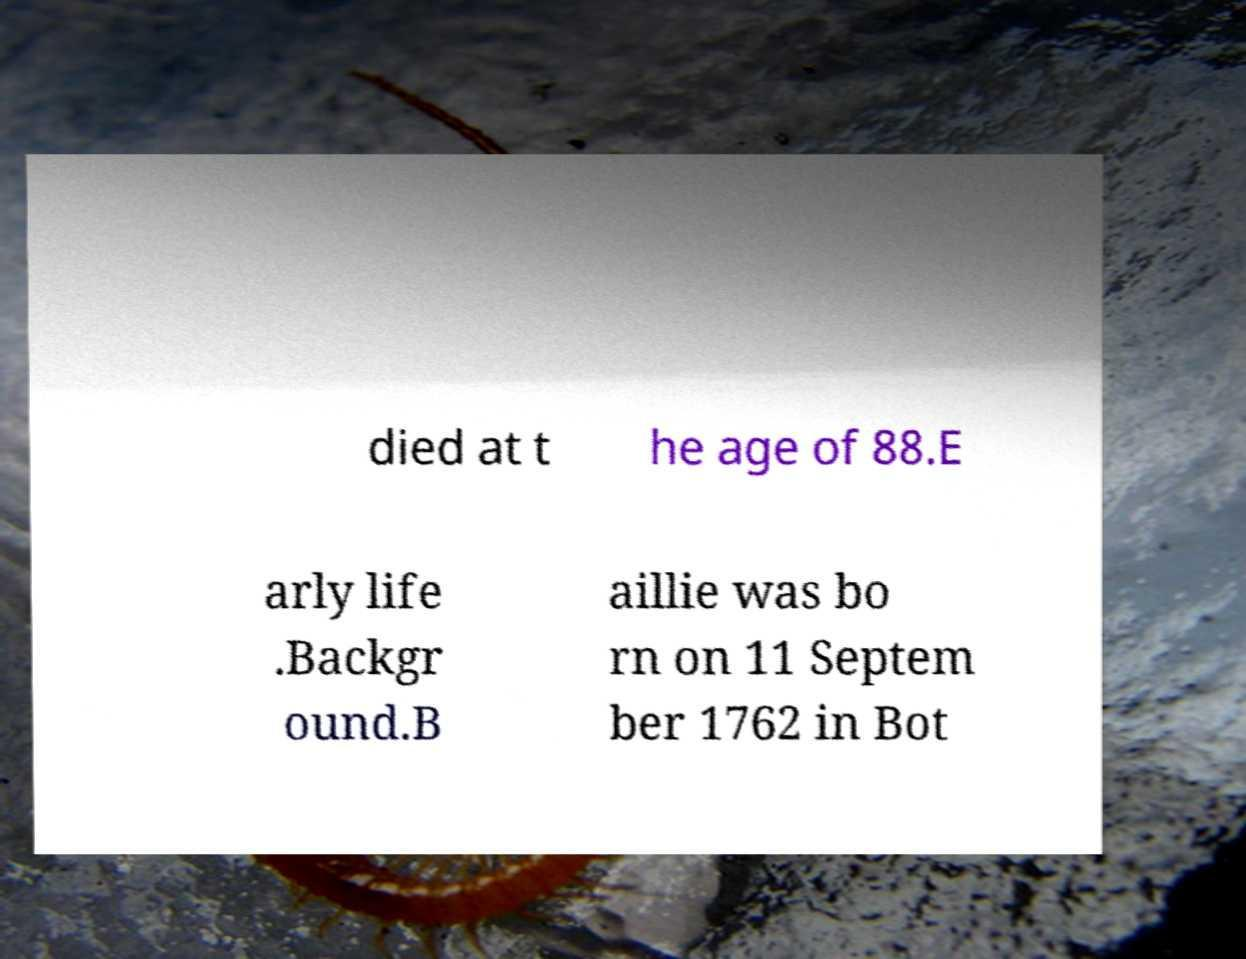Could you extract and type out the text from this image? died at t he age of 88.E arly life .Backgr ound.B aillie was bo rn on 11 Septem ber 1762 in Bot 